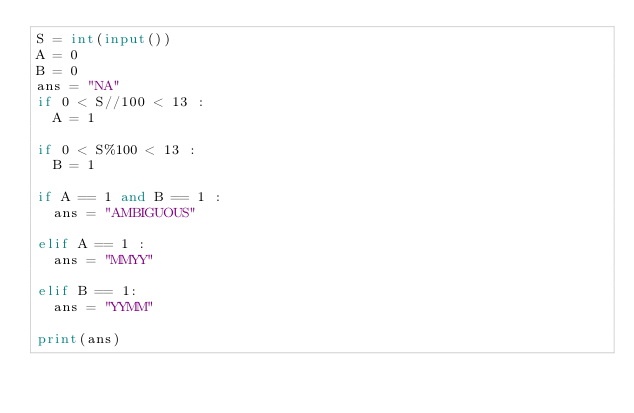Convert code to text. <code><loc_0><loc_0><loc_500><loc_500><_Python_>S = int(input())
A = 0
B = 0
ans = "NA"
if 0 < S//100 < 13 :
  A = 1

if 0 < S%100 < 13 :
  B = 1

if A == 1 and B == 1 :
  ans = "AMBIGUOUS"

elif A == 1 :
  ans = "MMYY"

elif B == 1:
  ans = "YYMM"

print(ans)</code> 